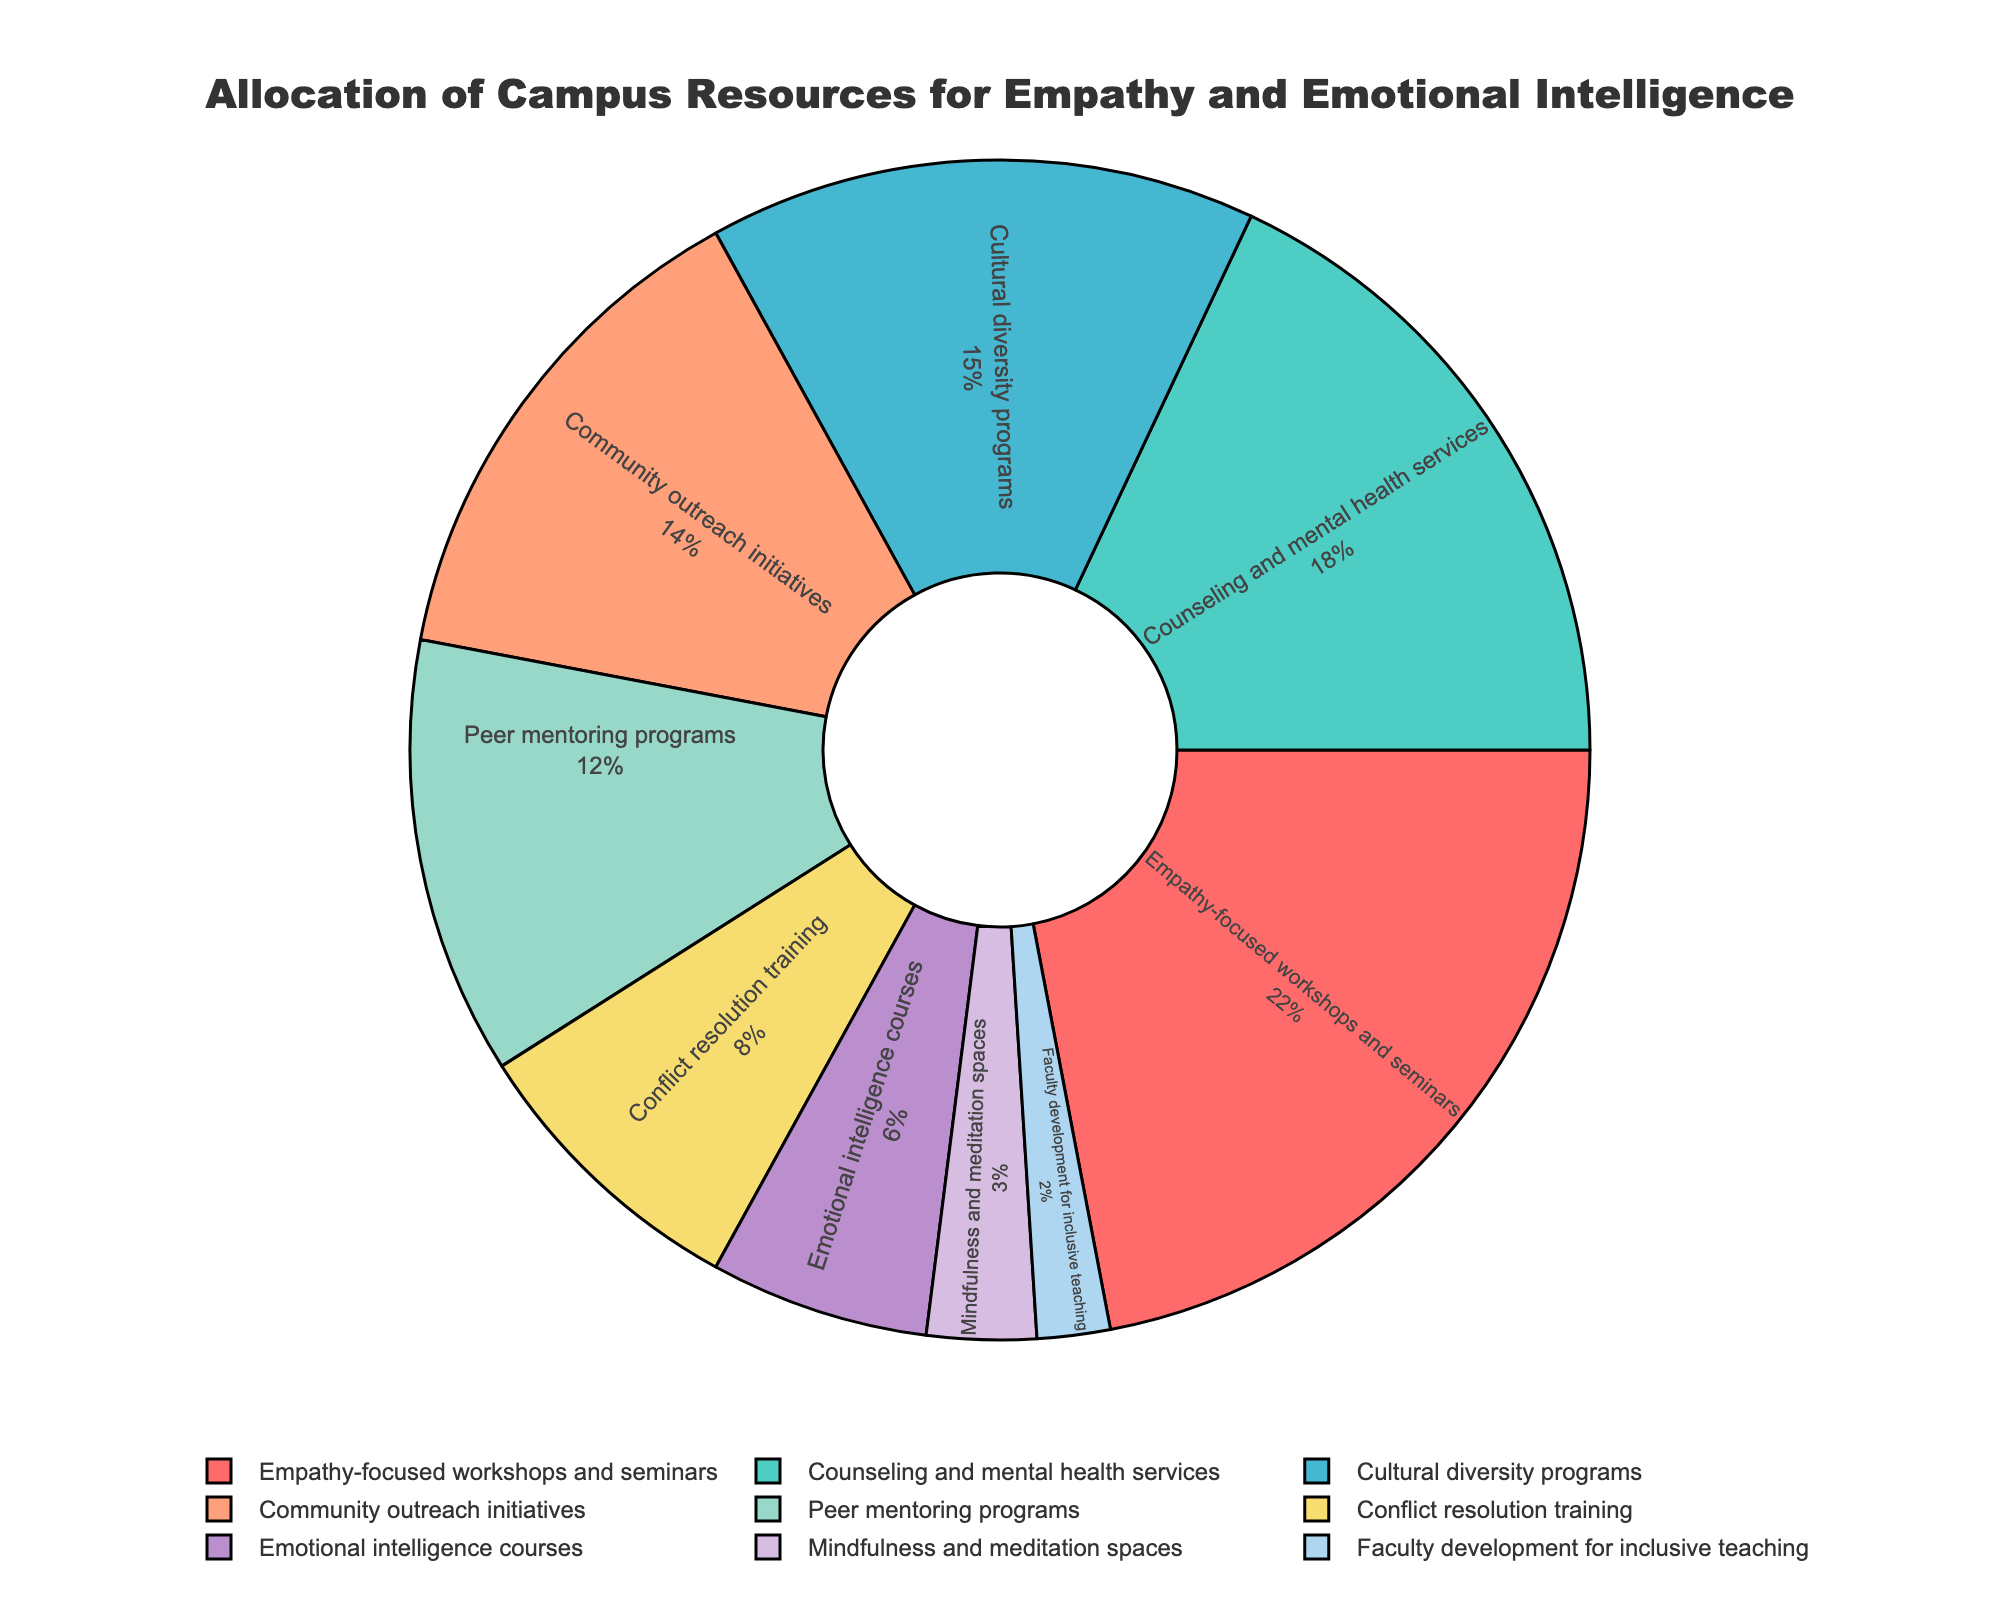What category receives the most allocation? To find which category receives the most allocation, look for the category with the highest percentage. Here, it is 'Empathy-focused workshops and seminars' with 22%.
Answer: Empathy-focused workshops and seminars What is the combined allocation percentage for Counseling and mental health services and Community outreach initiatives? To find the combined allocation, sum the percentages for 'Counseling and mental health services' and 'Community outreach initiatives'. This is 18% + 14% = 32%.
Answer: 32% Which category receives less allocation: Conflict resolution training or Emotional intelligence courses? Compare the percentages for 'Conflict resolution training' (8%) and 'Emotional intelligence courses' (6%). 'Emotional intelligence courses' receive less allocation.
Answer: Emotional intelligence courses What is the proportion between Peer mentoring programs and Faculty development for inclusive teaching? To find the proportion, divide the percentage of 'Peer mentoring programs' by 'Faculty development for inclusive teaching'. This is 12% / 2% = 6.
Answer: 6 What percentage of allocation is dedicated to Cultural diversity programs and Mindfulness and meditation spaces together? Sum the percentages for 'Cultural diversity programs' (15%) and 'Mindfulness and meditation spaces' (3%). This is 15% + 3% = 18%.
Answer: 18% Rank the top three categories by allocation percentage. Identify the top three categories with the highest percentages: 'Empathy-focused workshops and seminars' (22%), 'Counseling and mental health services' (18%), and 'Cultural diversity programs' (15%).
Answer: Empathy-focused workshops and seminars, Counseling and mental health services, Cultural diversity programs How much more allocation does Empathy-focused workshops and seminars receive compared to Peer mentoring programs? Calculate the difference in allocation between 'Empathy-focused workshops and seminars' (22%) and 'Peer mentoring programs' (12%). This is 22% - 12% = 10%.
Answer: 10% Which category is visually represented by purple? Look at the legend and match the color purple to the category. In this case, 'Faculty development for inclusive teaching' is represented by purple.
Answer: Faculty development for inclusive teaching What is the percentage range of the allocations? Identify the lowest and highest percentages, which are 'Faculty development for inclusive teaching' (2%) and 'Empathy-focused workshops and seminars' (22%). The range is 22% - 2% = 20%.
Answer: 20% What is the difference in allocation between the highest and lowest categories? The highest allocation is for 'Empathy-focused workshops and seminars' (22%), and the lowest is for 'Faculty development for inclusive teaching' (2%). The difference is 22% - 2% = 20%.
Answer: 20% 